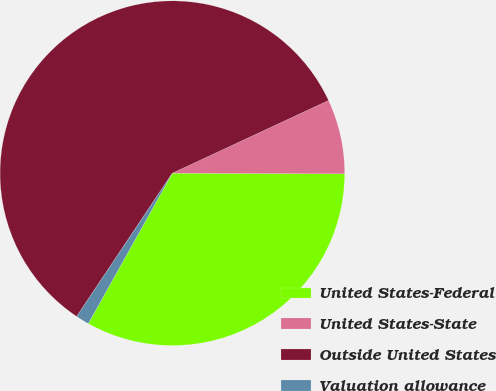Convert chart to OTSL. <chart><loc_0><loc_0><loc_500><loc_500><pie_chart><fcel>United States-Federal<fcel>United States-State<fcel>Outside United States<fcel>Valuation allowance<nl><fcel>33.05%<fcel>7.0%<fcel>58.69%<fcel>1.26%<nl></chart> 